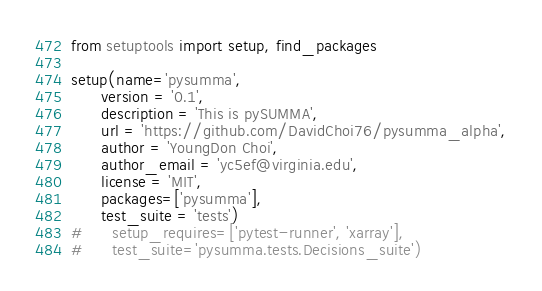Convert code to text. <code><loc_0><loc_0><loc_500><loc_500><_Python_>from setuptools import setup, find_packages

setup(name='pysumma',
      version = '0.1',
      description = 'This is pySUMMA',
      url = 'https://github.com/DavidChoi76/pysumma_alpha',
      author = 'YoungDon Choi',
      author_email = 'yc5ef@virginia.edu',
      license = 'MIT',
      packages=['pysumma'],
      test_suite = 'tests')
#      setup_requires=['pytest-runner', 'xarray'],
#      test_suite='pysumma.tests.Decisions_suite')
</code> 